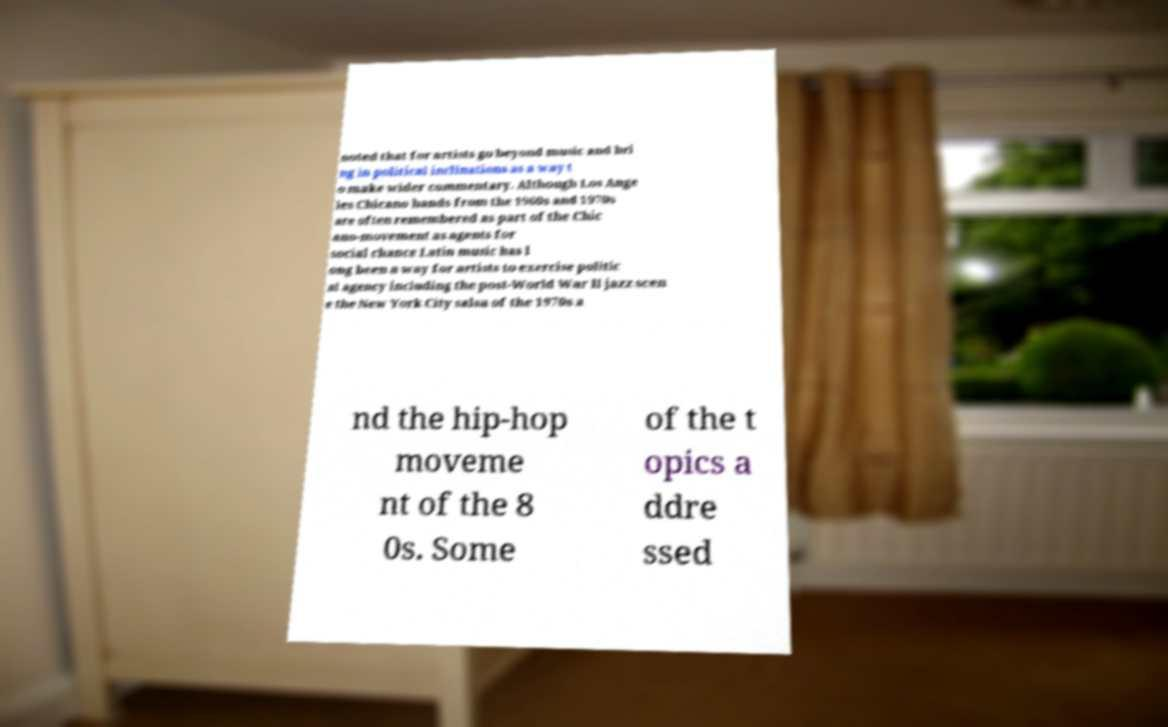For documentation purposes, I need the text within this image transcribed. Could you provide that? noted that for artists go beyond music and bri ng in political inclinations as a way t o make wider commentary. Although Los Ange les Chicano bands from the 1960s and 1970s are often remembered as part of the Chic ano-movement as agents for social chance Latin music has l ong been a way for artists to exercise politic al agency including the post-World War II jazz scen e the New York City salsa of the 1970s a nd the hip-hop moveme nt of the 8 0s. Some of the t opics a ddre ssed 